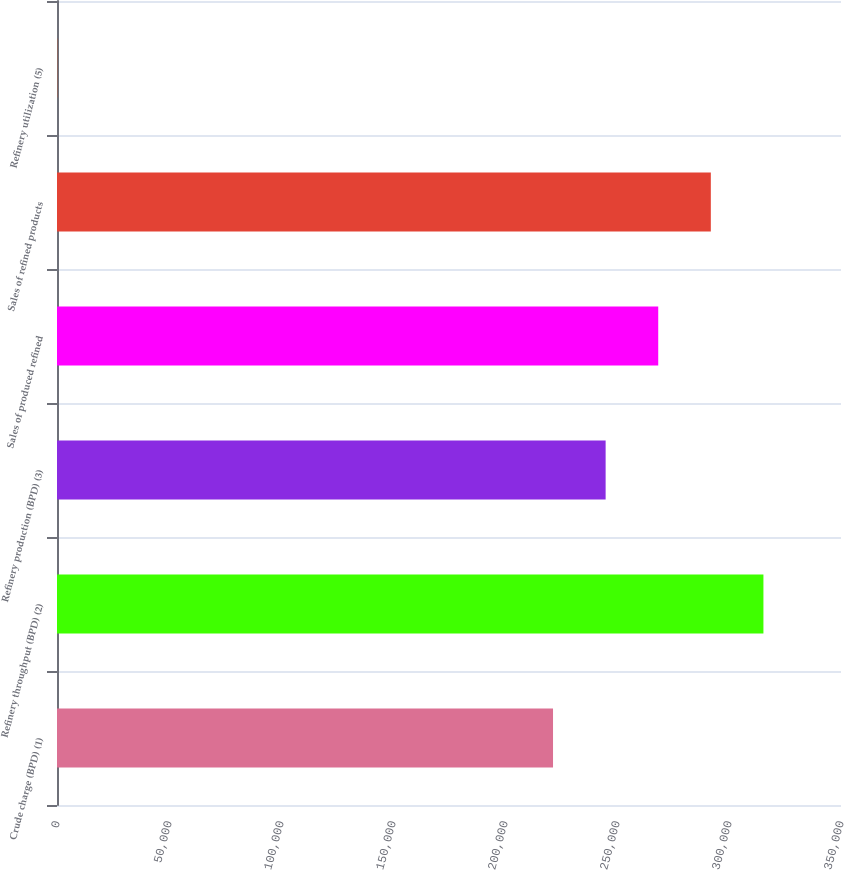Convert chart to OTSL. <chart><loc_0><loc_0><loc_500><loc_500><bar_chart><fcel>Crude charge (BPD) (1)<fcel>Refinery throughput (BPD) (2)<fcel>Refinery production (BPD) (3)<fcel>Sales of produced refined<fcel>Sales of refined products<fcel>Refinery utilization (5)<nl><fcel>221440<fcel>315369<fcel>244922<fcel>268405<fcel>291887<fcel>86.5<nl></chart> 